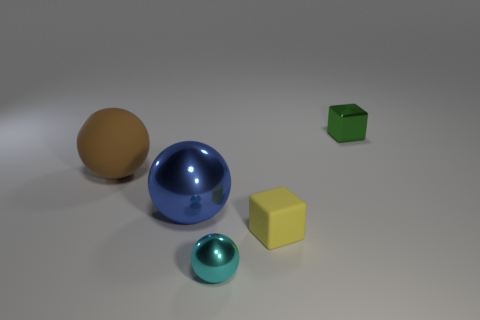How many other objects are there of the same material as the cyan sphere?
Provide a succinct answer. 2. Are there any blue metallic spheres to the right of the large blue sphere?
Your answer should be compact. No. There is a green block; is its size the same as the metallic ball behind the yellow rubber object?
Offer a terse response. No. What color is the tiny block to the left of the small cube that is right of the small matte object?
Make the answer very short. Yellow. Do the green metallic thing and the blue sphere have the same size?
Make the answer very short. No. There is a object that is behind the blue object and in front of the green metallic cube; what color is it?
Ensure brevity in your answer.  Brown. The brown matte thing is what size?
Provide a succinct answer. Large. Is the color of the sphere left of the big metallic ball the same as the tiny shiny cube?
Give a very brief answer. No. Are there more brown matte objects behind the brown thing than things that are in front of the large shiny ball?
Make the answer very short. No. Is the number of large red metallic spheres greater than the number of blocks?
Keep it short and to the point. No. 